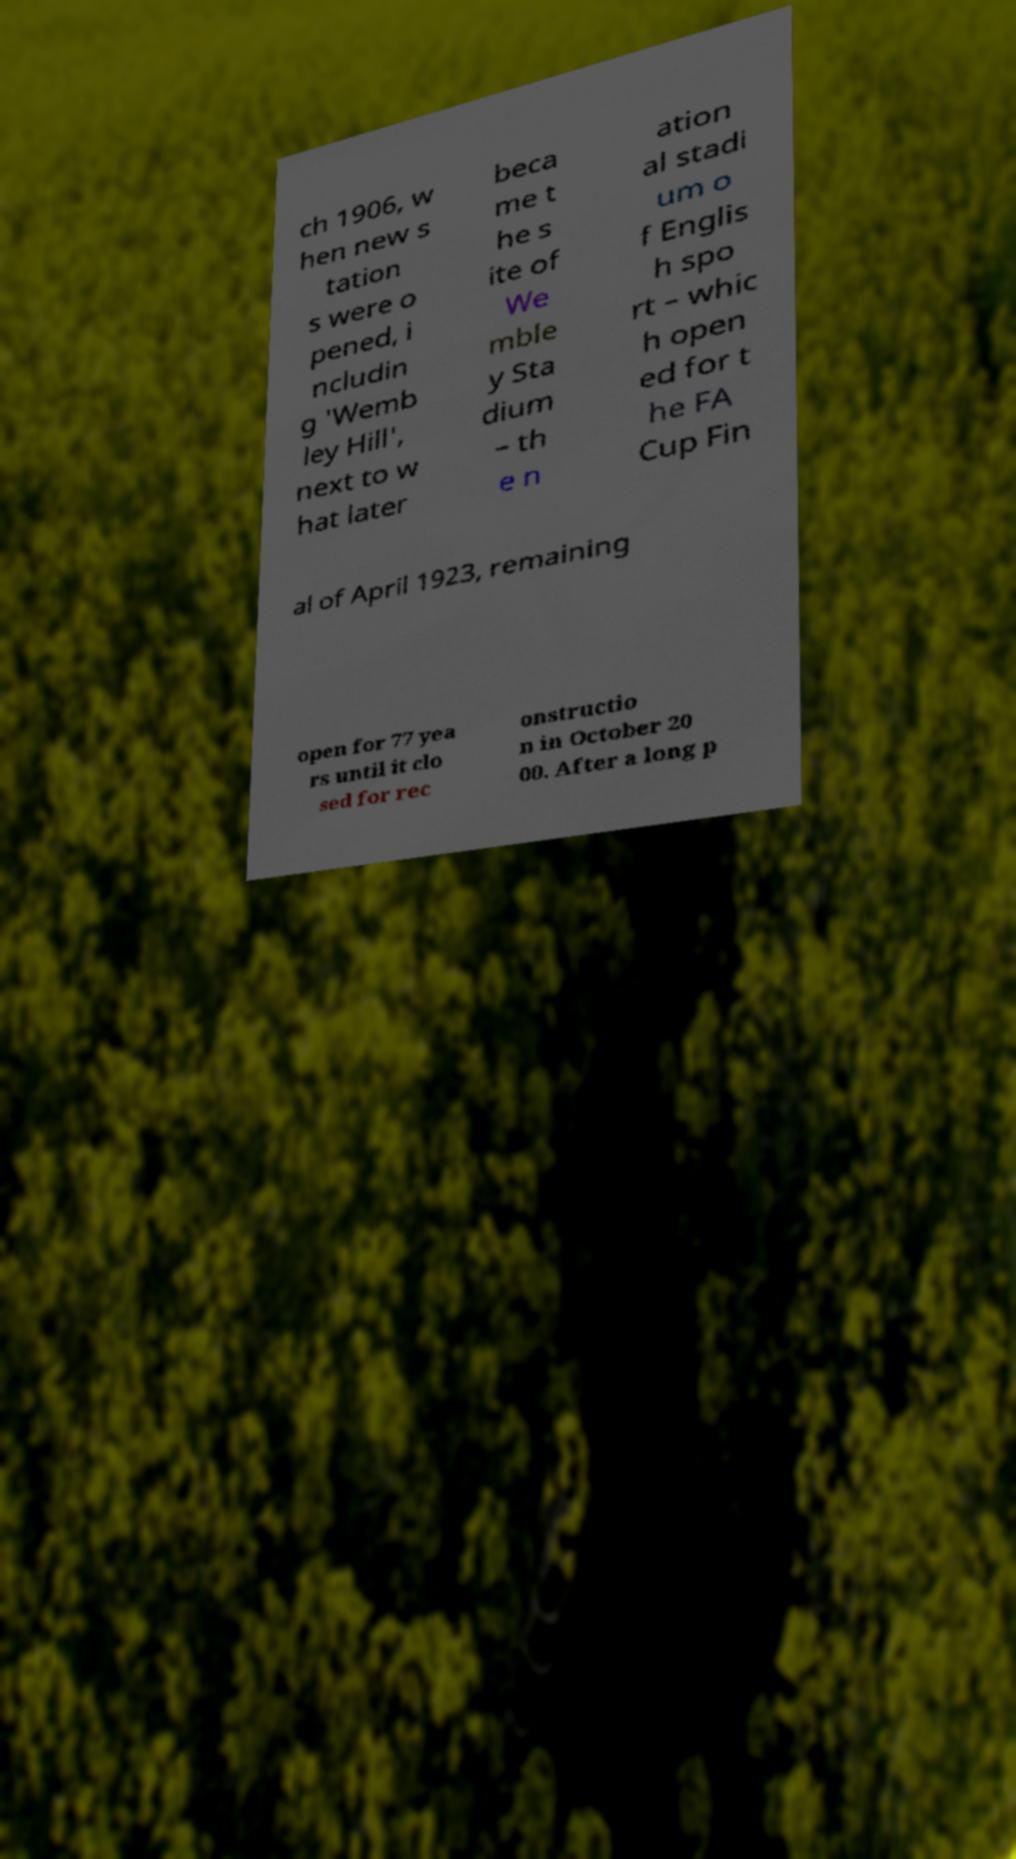For documentation purposes, I need the text within this image transcribed. Could you provide that? ch 1906, w hen new s tation s were o pened, i ncludin g 'Wemb ley Hill', next to w hat later beca me t he s ite of We mble y Sta dium – th e n ation al stadi um o f Englis h spo rt – whic h open ed for t he FA Cup Fin al of April 1923, remaining open for 77 yea rs until it clo sed for rec onstructio n in October 20 00. After a long p 